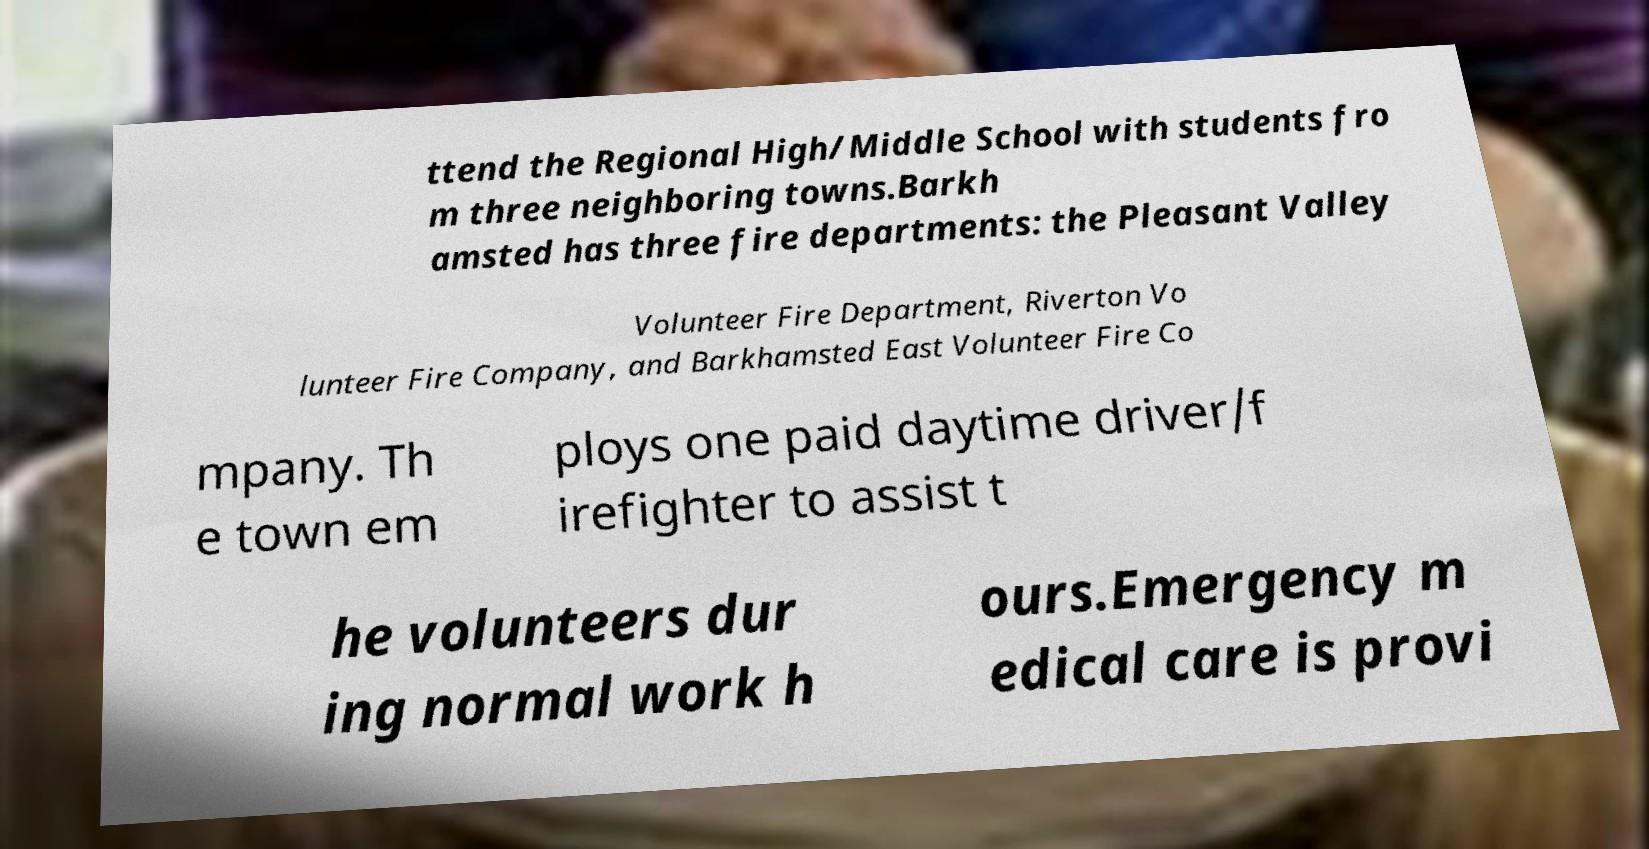What messages or text are displayed in this image? I need them in a readable, typed format. ttend the Regional High/Middle School with students fro m three neighboring towns.Barkh amsted has three fire departments: the Pleasant Valley Volunteer Fire Department, Riverton Vo lunteer Fire Company, and Barkhamsted East Volunteer Fire Co mpany. Th e town em ploys one paid daytime driver/f irefighter to assist t he volunteers dur ing normal work h ours.Emergency m edical care is provi 